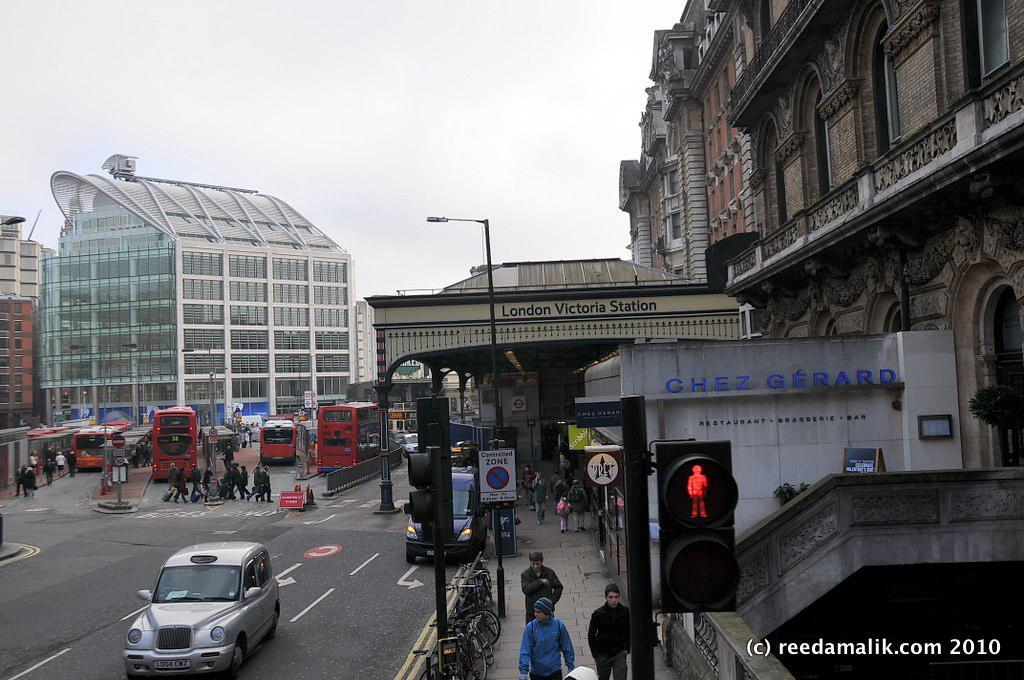<image>
Relay a brief, clear account of the picture shown. A group of people are walking down a sidewalk by a building that says Chez Gerard. 